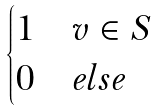Convert formula to latex. <formula><loc_0><loc_0><loc_500><loc_500>\begin{cases} 1 & v \in S \\ 0 & e l s e \end{cases}</formula> 